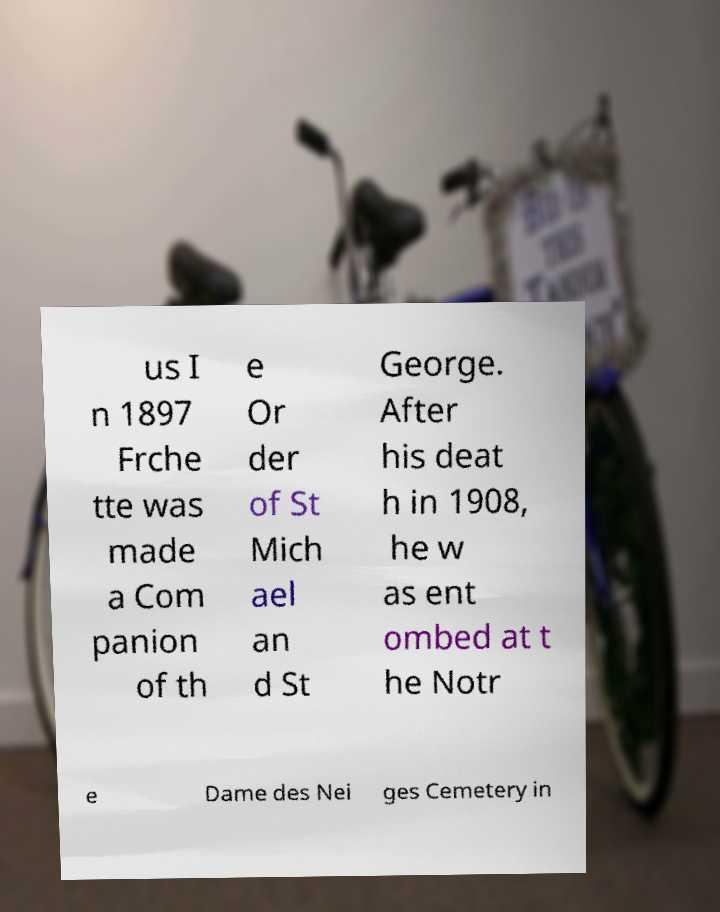Please read and relay the text visible in this image. What does it say? us I n 1897 Frche tte was made a Com panion of th e Or der of St Mich ael an d St George. After his deat h in 1908, he w as ent ombed at t he Notr e Dame des Nei ges Cemetery in 